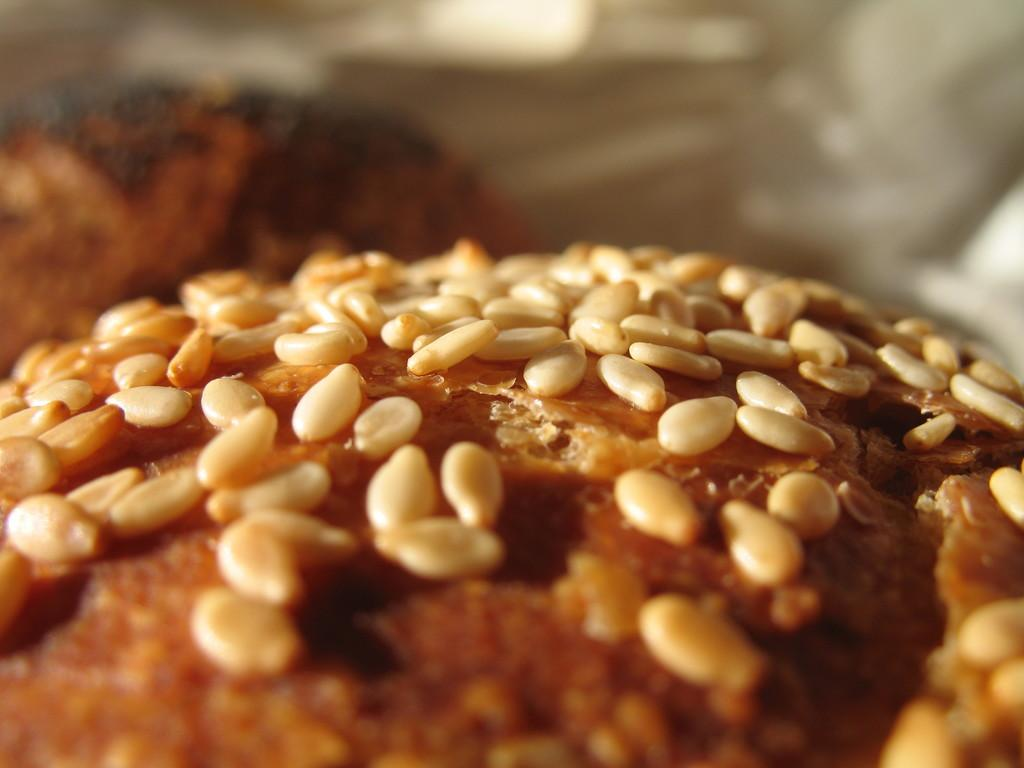What is the main subject of the image? The main subject of the image is a cupcake. Can you describe the cupcake in more detail? Yes, the cupcake has seeds on it. How much zinc is present in the cupcake in the image? There is no information about the zinc content of the cupcake in the image, so it cannot be determined. 